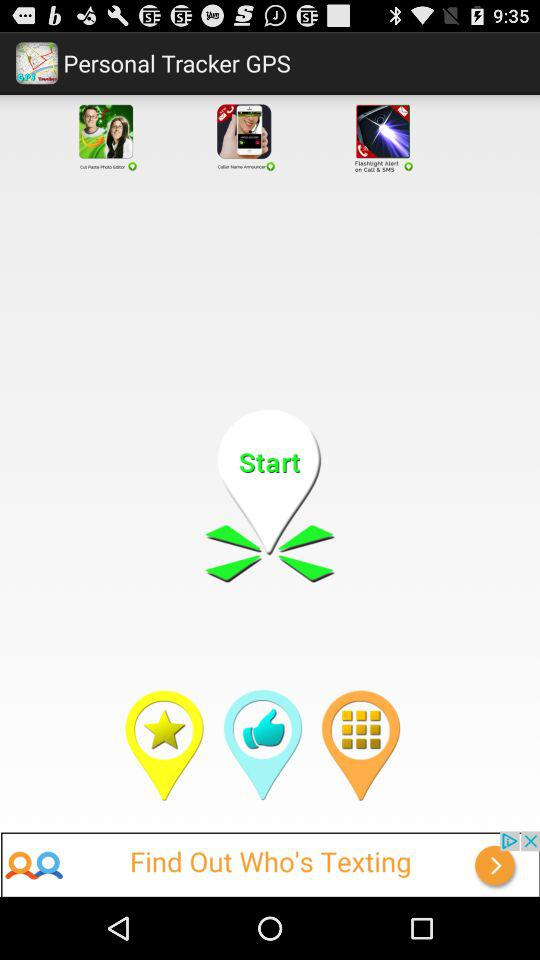What is the name of the application? The name of the application is "Personal Tracker GPS". 